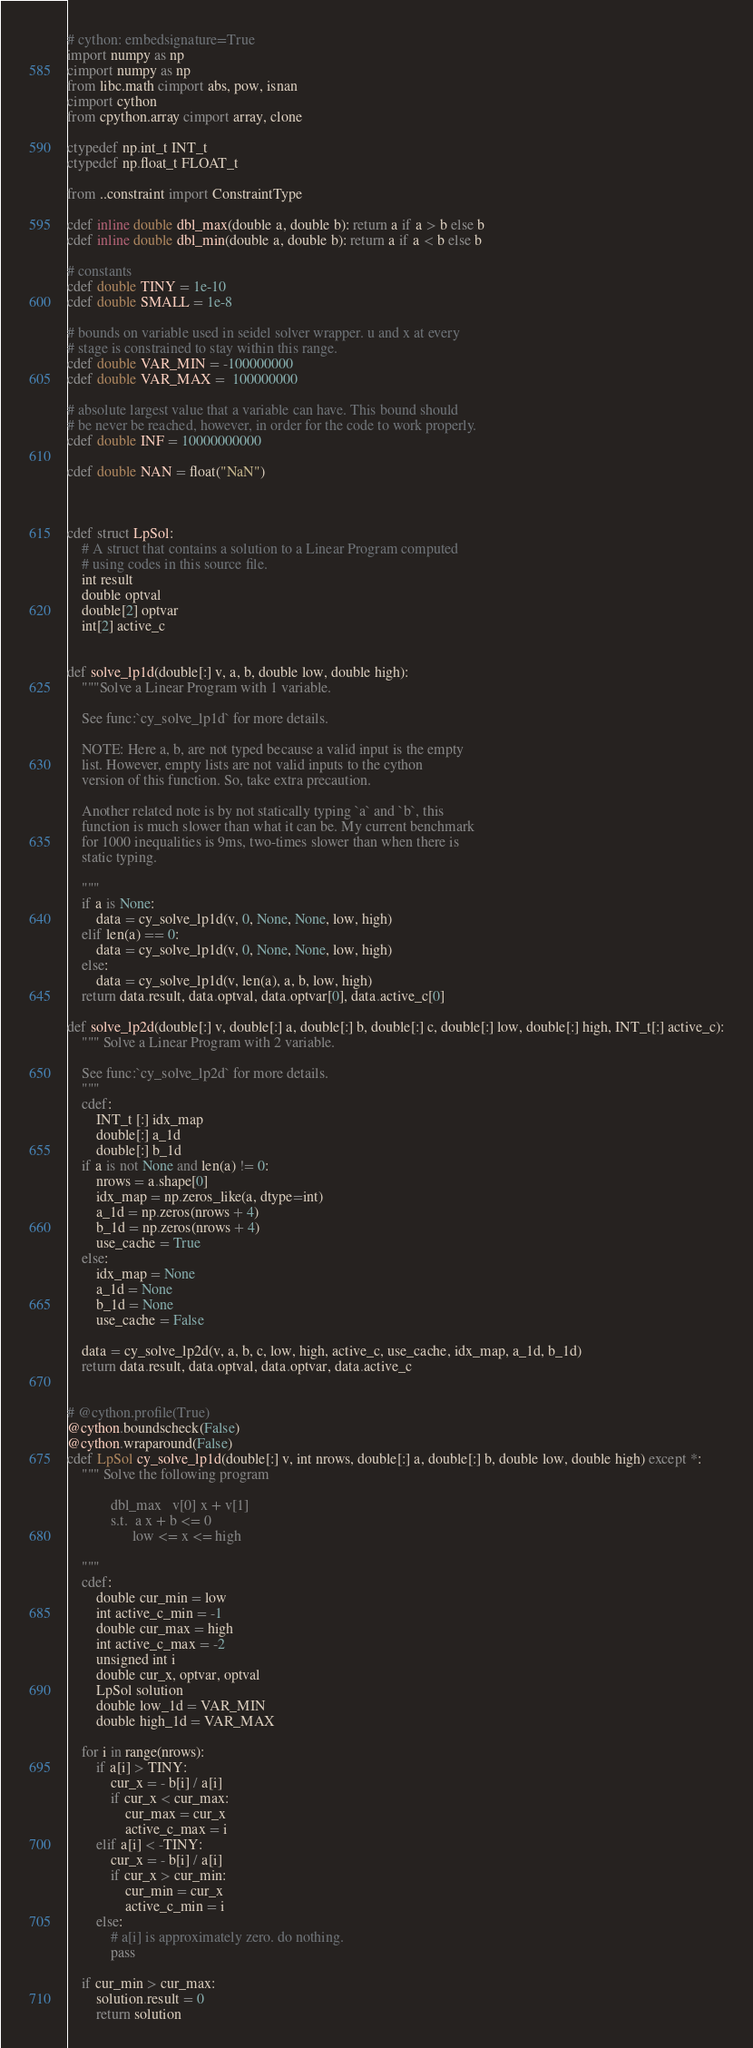<code> <loc_0><loc_0><loc_500><loc_500><_Cython_># cython: embedsignature=True
import numpy as np
cimport numpy as np
from libc.math cimport abs, pow, isnan
cimport cython
from cpython.array cimport array, clone

ctypedef np.int_t INT_t
ctypedef np.float_t FLOAT_t

from ..constraint import ConstraintType

cdef inline double dbl_max(double a, double b): return a if a > b else b
cdef inline double dbl_min(double a, double b): return a if a < b else b

# constants
cdef double TINY = 1e-10
cdef double SMALL = 1e-8

# bounds on variable used in seidel solver wrapper. u and x at every
# stage is constrained to stay within this range.
cdef double VAR_MIN = -100000000  
cdef double VAR_MAX =  100000000

# absolute largest value that a variable can have. This bound should
# be never be reached, however, in order for the code to work properly.
cdef double INF = 10000000000  

cdef double NAN = float("NaN")



cdef struct LpSol:
    # A struct that contains a solution to a Linear Program computed
    # using codes in this source file.
    int result
    double optval
    double[2] optvar
    int[2] active_c


def solve_lp1d(double[:] v, a, b, double low, double high):
    """Solve a Linear Program with 1 variable.

    See func:`cy_solve_lp1d` for more details.

    NOTE: Here a, b, are not typed because a valid input is the empty
    list. However, empty lists are not valid inputs to the cython
    version of this function. So, take extra precaution. 

    Another related note is by not statically typing `a` and `b`, this
    function is much slower than what it can be. My current benchmark
    for 1000 inequalities is 9ms, two-times slower than when there is
    static typing.

    """
    if a is None:
        data = cy_solve_lp1d(v, 0, None, None, low, high)
    elif len(a) == 0:
        data = cy_solve_lp1d(v, 0, None, None, low, high)
    else:
        data = cy_solve_lp1d(v, len(a), a, b, low, high)
    return data.result, data.optval, data.optvar[0], data.active_c[0]

def solve_lp2d(double[:] v, double[:] a, double[:] b, double[:] c, double[:] low, double[:] high, INT_t[:] active_c):
    """ Solve a Linear Program with 2 variable.

    See func:`cy_solve_lp2d` for more details.
    """
    cdef:
        INT_t [:] idx_map
        double[:] a_1d
        double[:] b_1d
    if a is not None and len(a) != 0:
        nrows = a.shape[0]
        idx_map = np.zeros_like(a, dtype=int)
        a_1d = np.zeros(nrows + 4)
        b_1d = np.zeros(nrows + 4)
        use_cache = True
    else:
        idx_map = None
        a_1d = None
        b_1d = None
        use_cache = False

    data = cy_solve_lp2d(v, a, b, c, low, high, active_c, use_cache, idx_map, a_1d, b_1d)
    return data.result, data.optval, data.optvar, data.active_c


# @cython.profile(True)
@cython.boundscheck(False)
@cython.wraparound(False)
cdef LpSol cy_solve_lp1d(double[:] v, int nrows, double[:] a, double[:] b, double low, double high) except *:
    """ Solve the following program
    
            dbl_max   v[0] x + v[1]
            s.t.  a x + b <= 0
                  low <= x <= high

    """
    cdef:
        double cur_min = low
        int active_c_min = -1
        double cur_max = high
        int active_c_max = -2
        unsigned int i
        double cur_x, optvar, optval
        LpSol solution
        double low_1d = VAR_MIN
        double high_1d = VAR_MAX

    for i in range(nrows):
        if a[i] > TINY:
            cur_x = - b[i] / a[i]
            if cur_x < cur_max:
                cur_max = cur_x
                active_c_max = i
        elif a[i] < -TINY:
            cur_x = - b[i] / a[i]
            if cur_x > cur_min:
                cur_min = cur_x
                active_c_min = i
        else:
            # a[i] is approximately zero. do nothing.
            pass

    if cur_min > cur_max:
        solution.result = 0
        return solution
</code> 